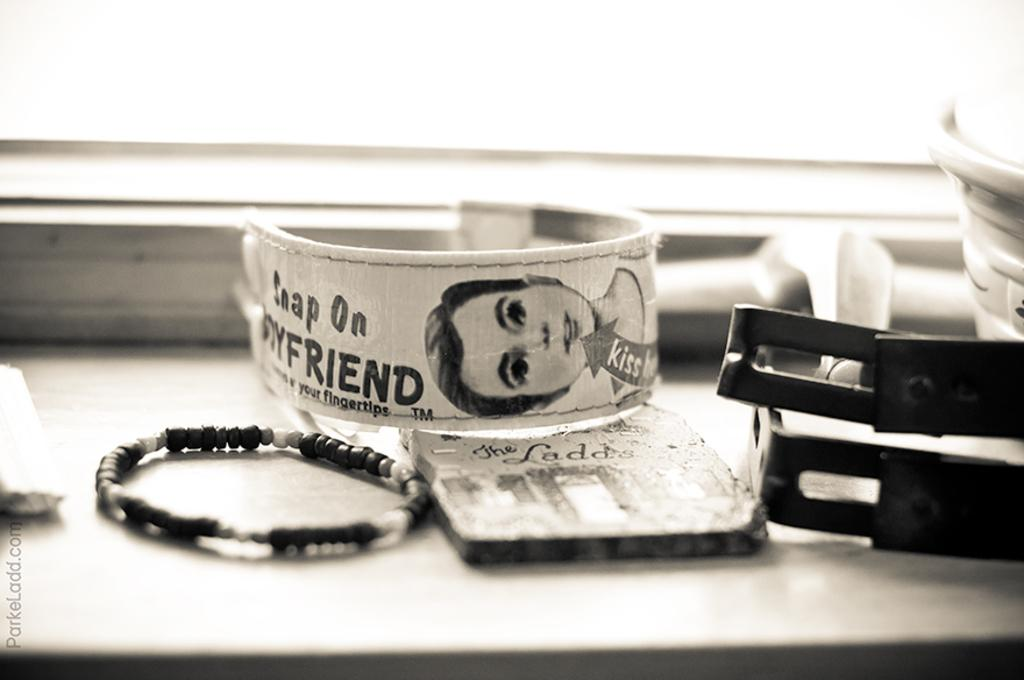What type of accessory is present in the image? There is a bracelet in the image. What material is used for some of the objects in the image? There are objects made up of metal in the image. How many items in the image have a white color? There are two things in white color in the image. What can be seen in the background of the image? There appears to be a window in the background of the image. What is the name of the boy holding the cannon in the image? There is no boy or cannon present in the image. 